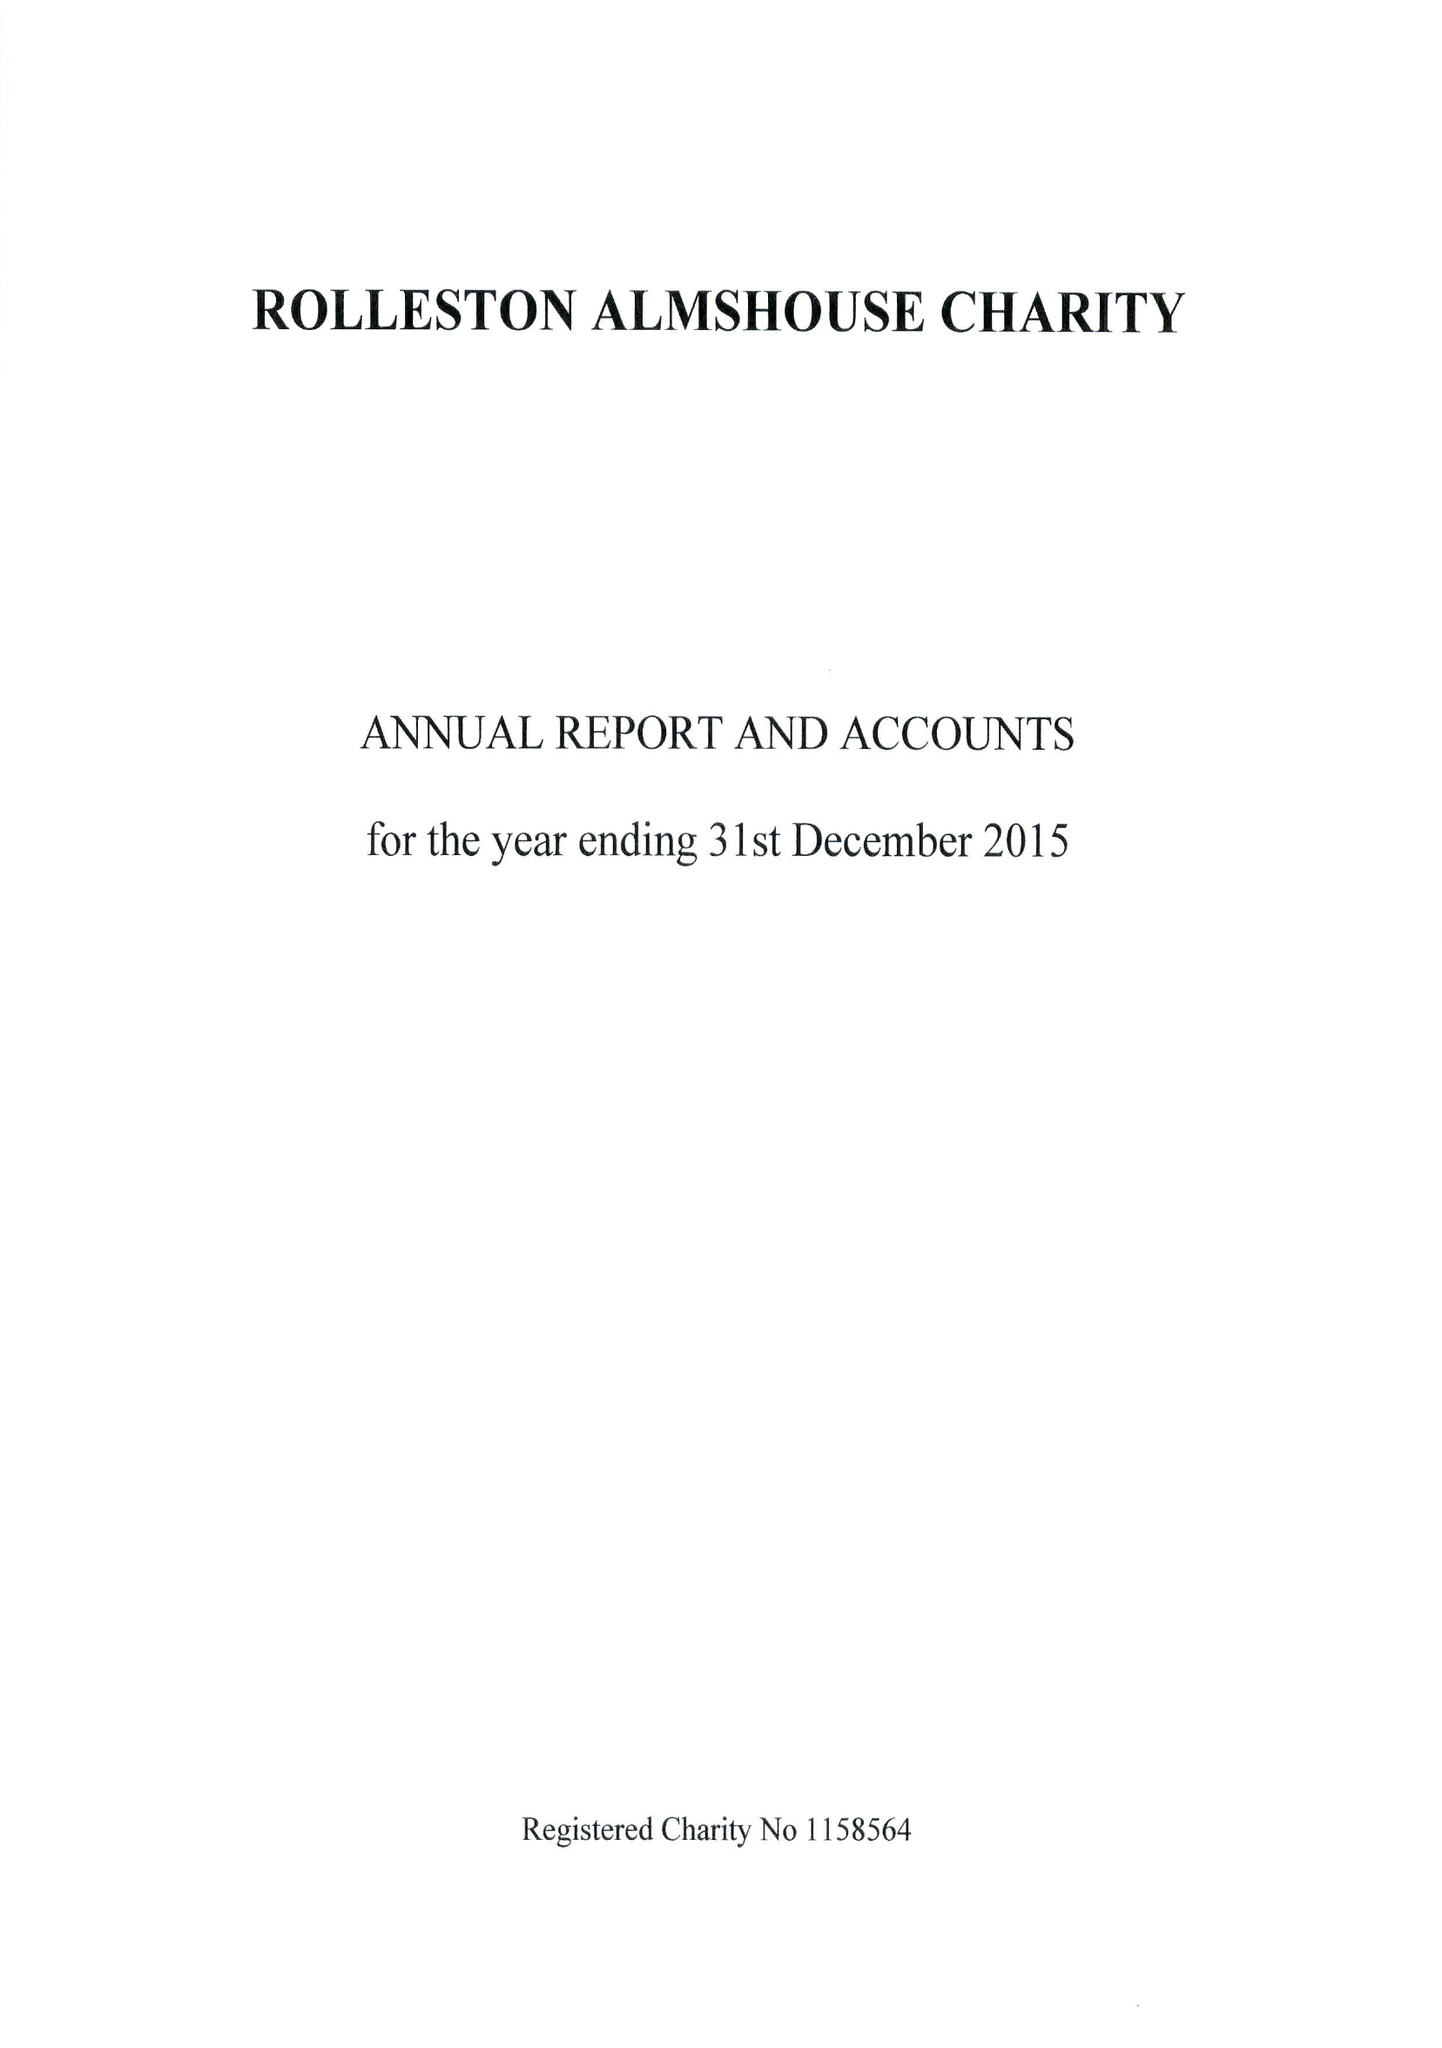What is the value for the spending_annually_in_british_pounds?
Answer the question using a single word or phrase. 14509.00 